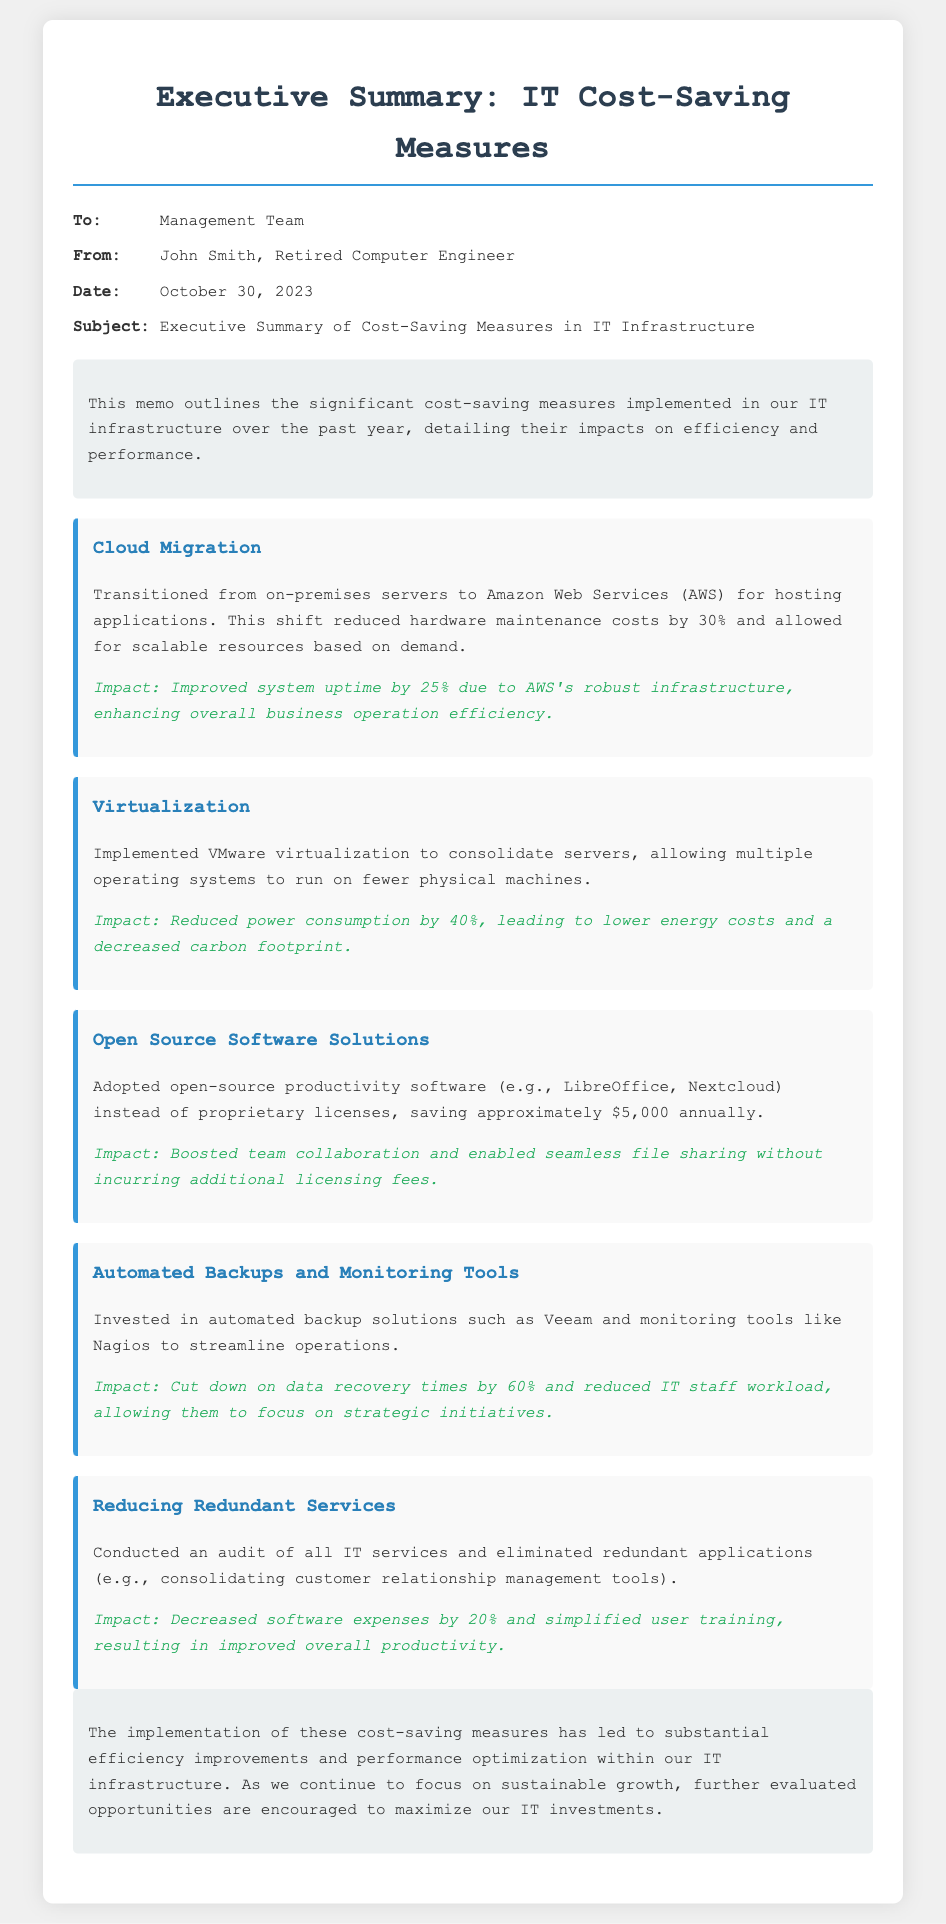what is the date of the memo? The date of the memo is mentioned in the meta section, which states October 30, 2023.
Answer: October 30, 2023 who is the author of the memo? The author is identified in the meta section as John Smith.
Answer: John Smith what cost reduction percentage was achieved through cloud migration? The document states that hardware maintenance costs were reduced by 30% due to cloud migration.
Answer: 30% how much was saved annually by adopting open source software solutions? The memo specifies that approximately $5,000 was saved annually with open-source software solutions.
Answer: $5,000 what impact did virtualization have on power consumption? The document states that virtualization led to a 40% reduction in power consumption.
Answer: 40% how much did data recovery times decrease with automated backups? The memo mentions a 60% cut in data recovery times due to automated backup solutions.
Answer: 60% which IT tool was mentioned for monitoring? The document lists Nagios as a monitoring tool that was invested in.
Answer: Nagios what is the main conclusion of the memo? The conclusion emphasizes the substantial efficiency improvements and performance optimization due to the cost-saving measures.
Answer: Substantial efficiency improvements and performance optimization how did reducing redundant services impact software expenses? The memo states that reducing redundant services decreased software expenses by 20%.
Answer: 20% 